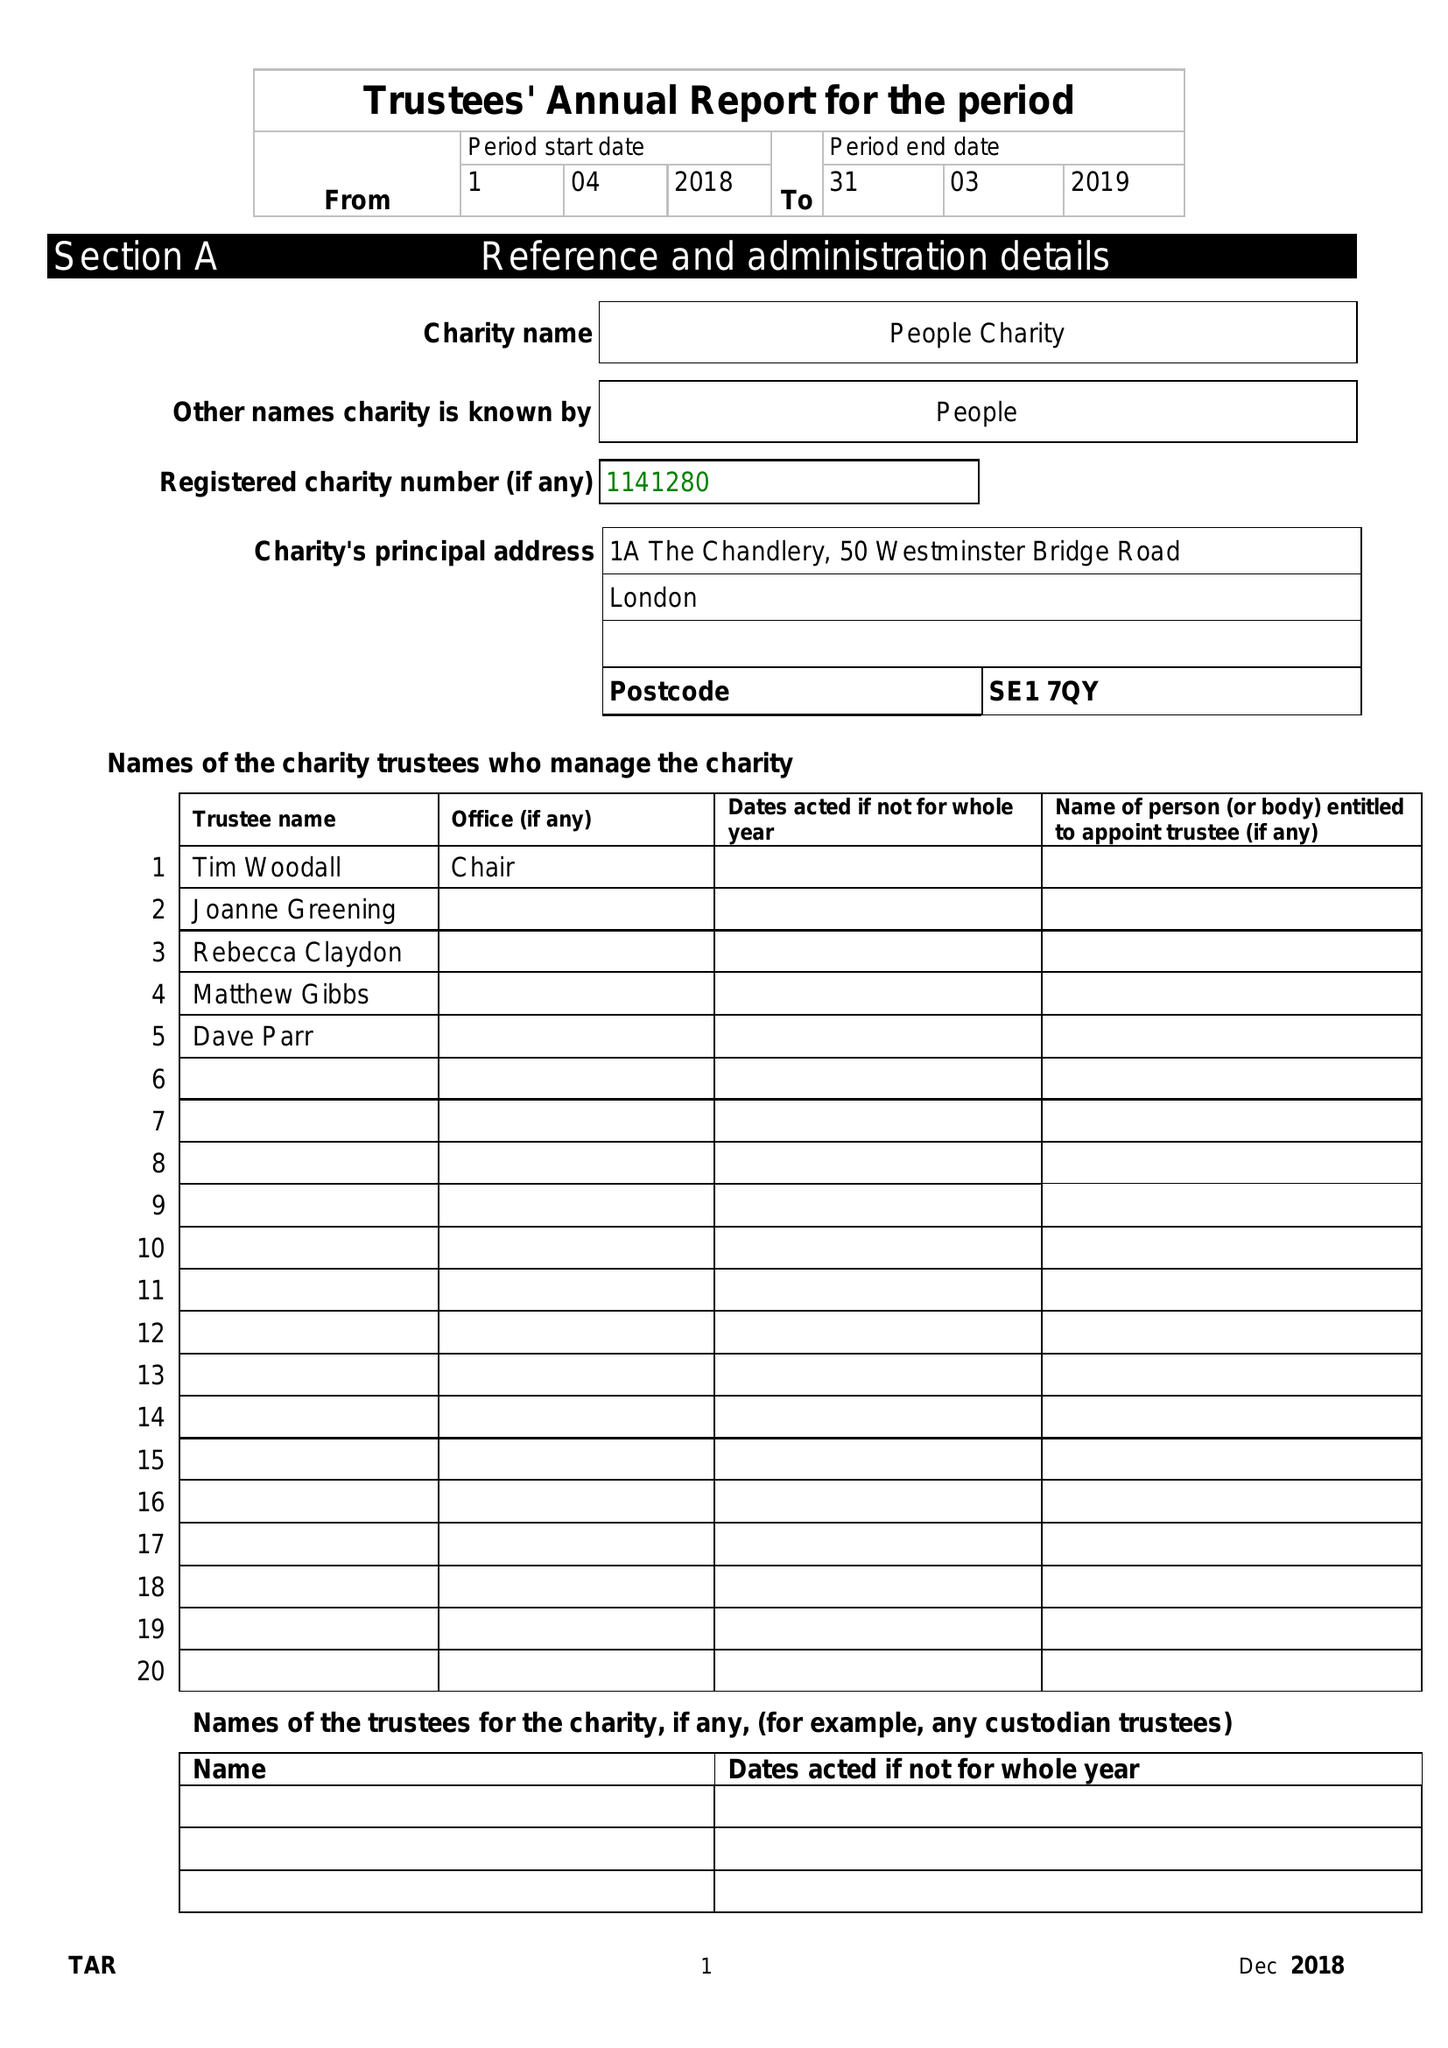What is the value for the charity_number?
Answer the question using a single word or phrase. 1141280 